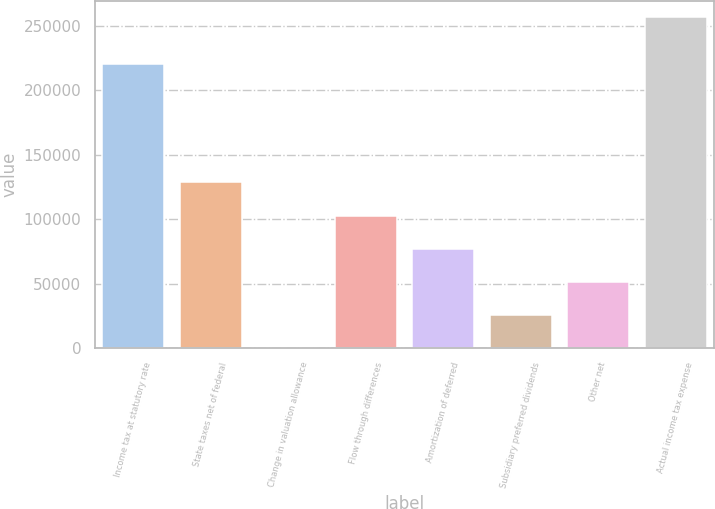<chart> <loc_0><loc_0><loc_500><loc_500><bar_chart><fcel>Income tax at statutory rate<fcel>State taxes net of federal<fcel>Change in valuation allowance<fcel>Flow through differences<fcel>Amortization of deferred<fcel>Subsidiary preferred dividends<fcel>Other net<fcel>Actual income tax expense<nl><fcel>220940<fcel>128576<fcel>143<fcel>102889<fcel>77202.5<fcel>25829.5<fcel>51516<fcel>257008<nl></chart> 